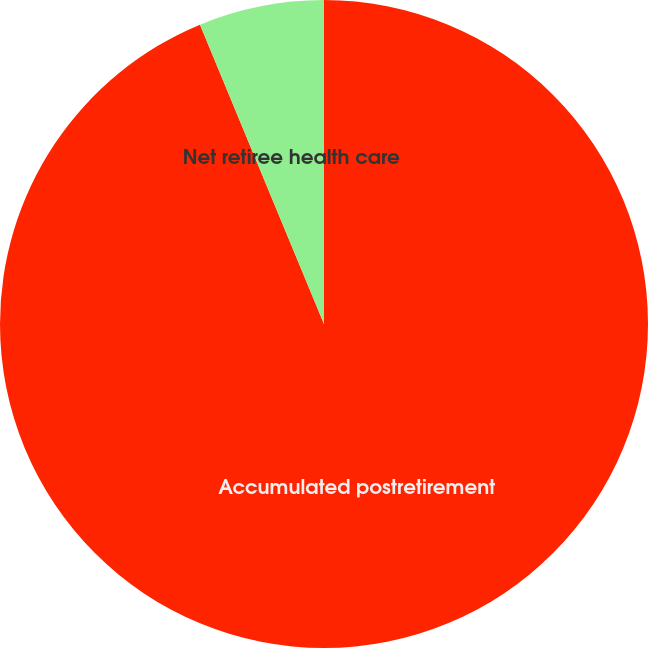Convert chart. <chart><loc_0><loc_0><loc_500><loc_500><pie_chart><fcel>Accumulated postretirement<fcel>Net retiree health care<nl><fcel>93.75%<fcel>6.25%<nl></chart> 